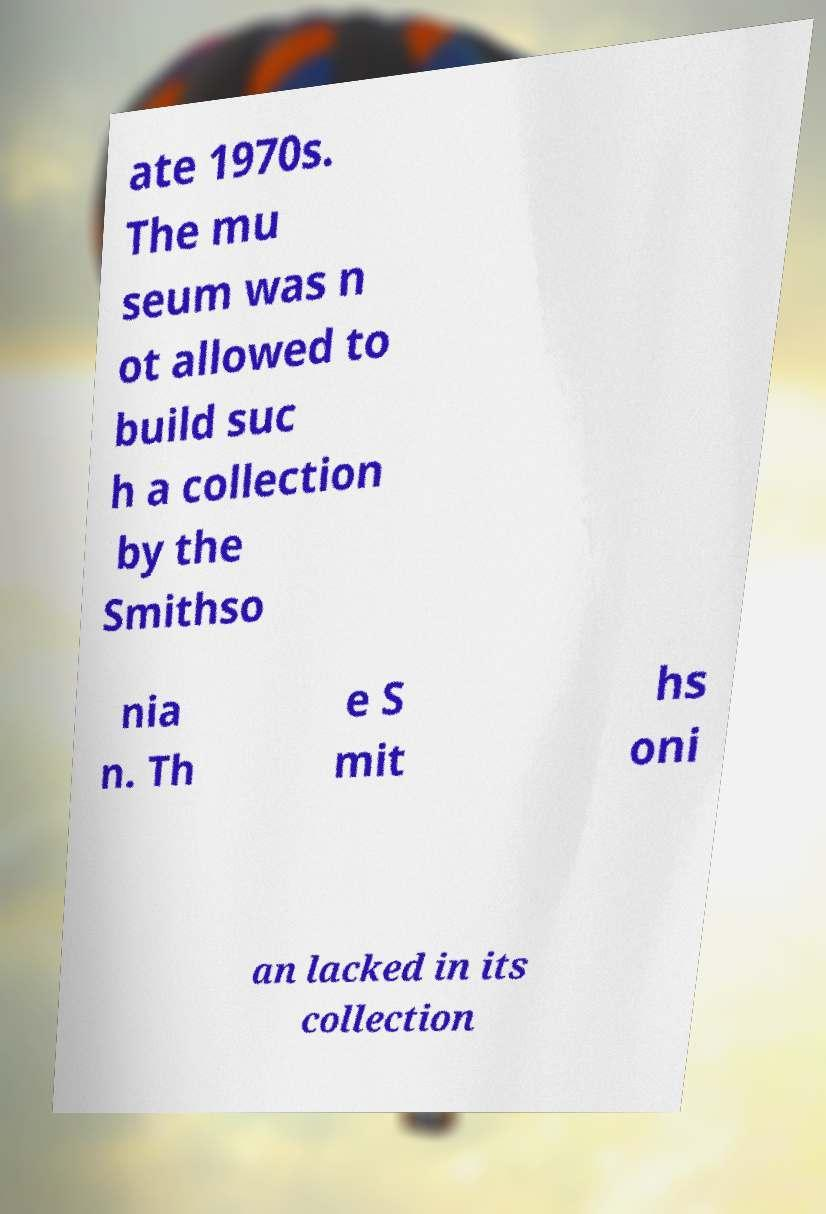Could you extract and type out the text from this image? ate 1970s. The mu seum was n ot allowed to build suc h a collection by the Smithso nia n. Th e S mit hs oni an lacked in its collection 